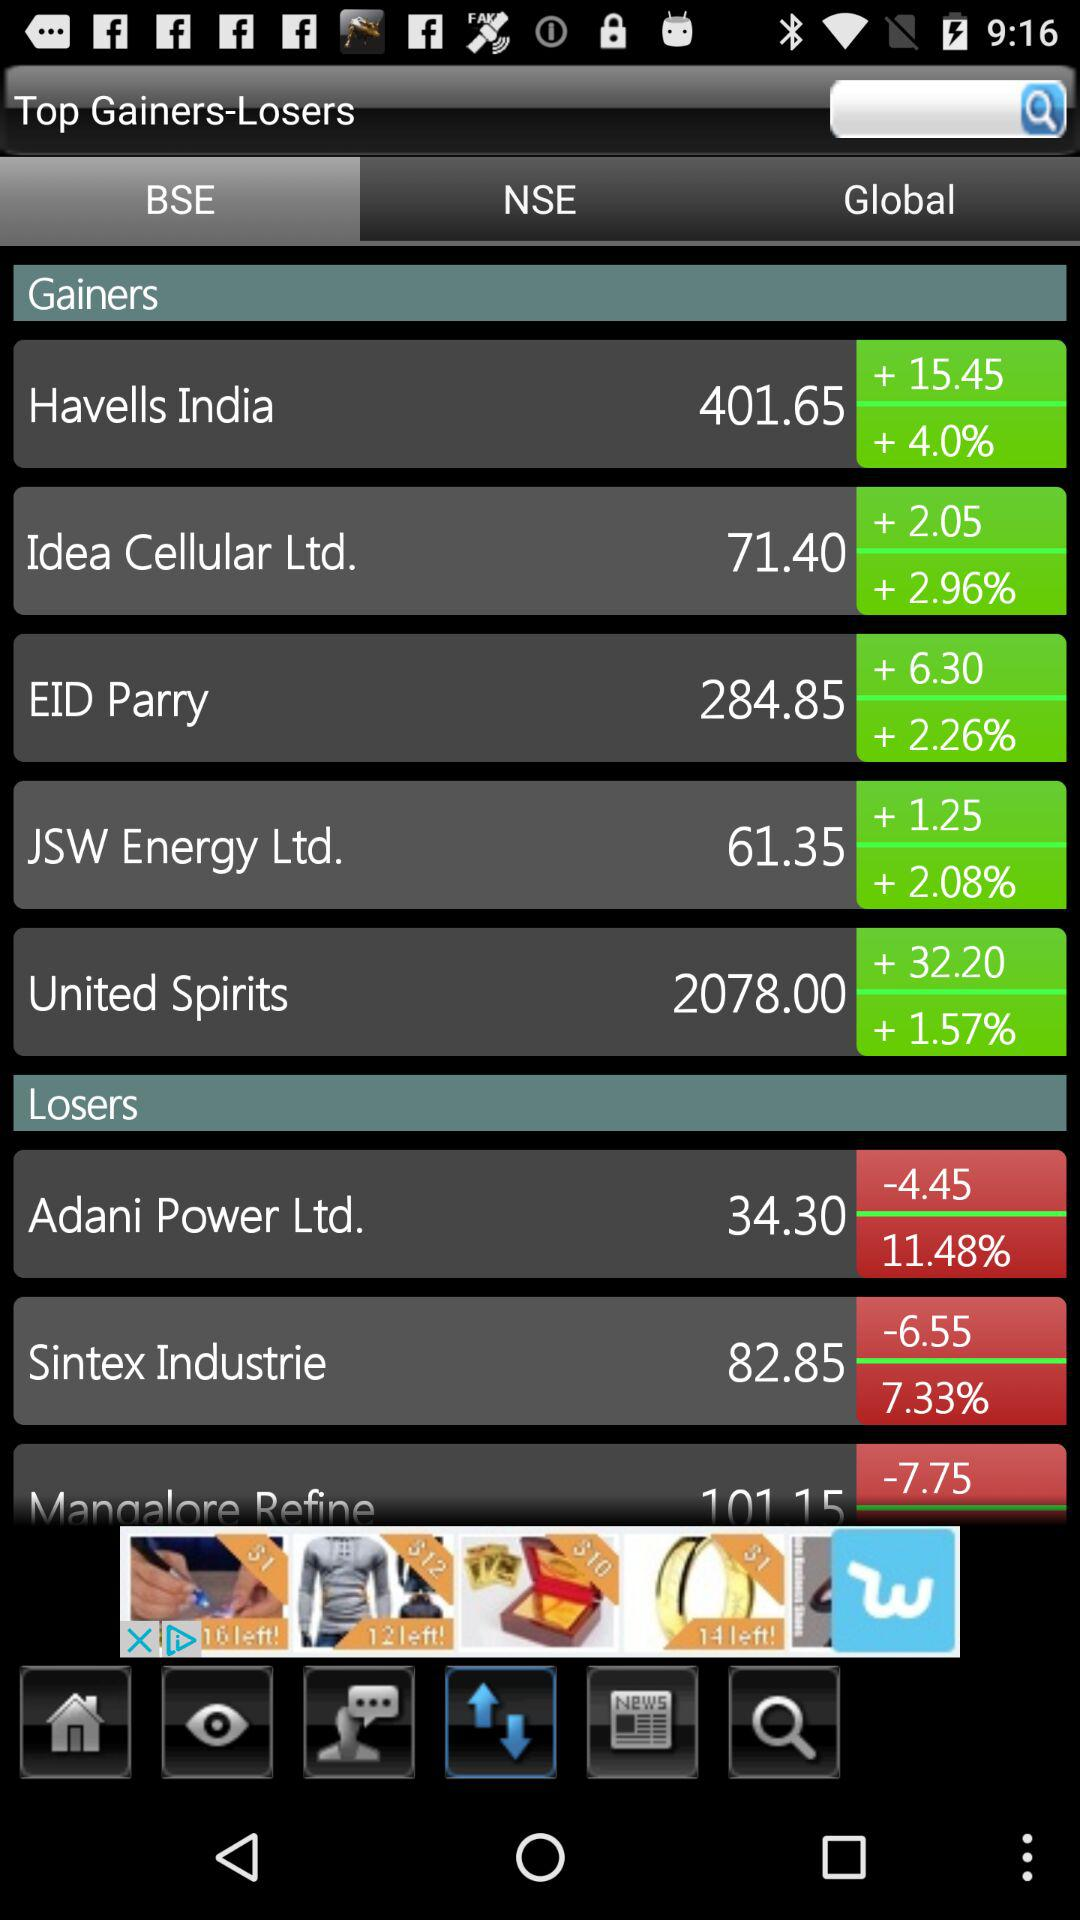How many gainers are there?
Answer the question using a single word or phrase. 5 